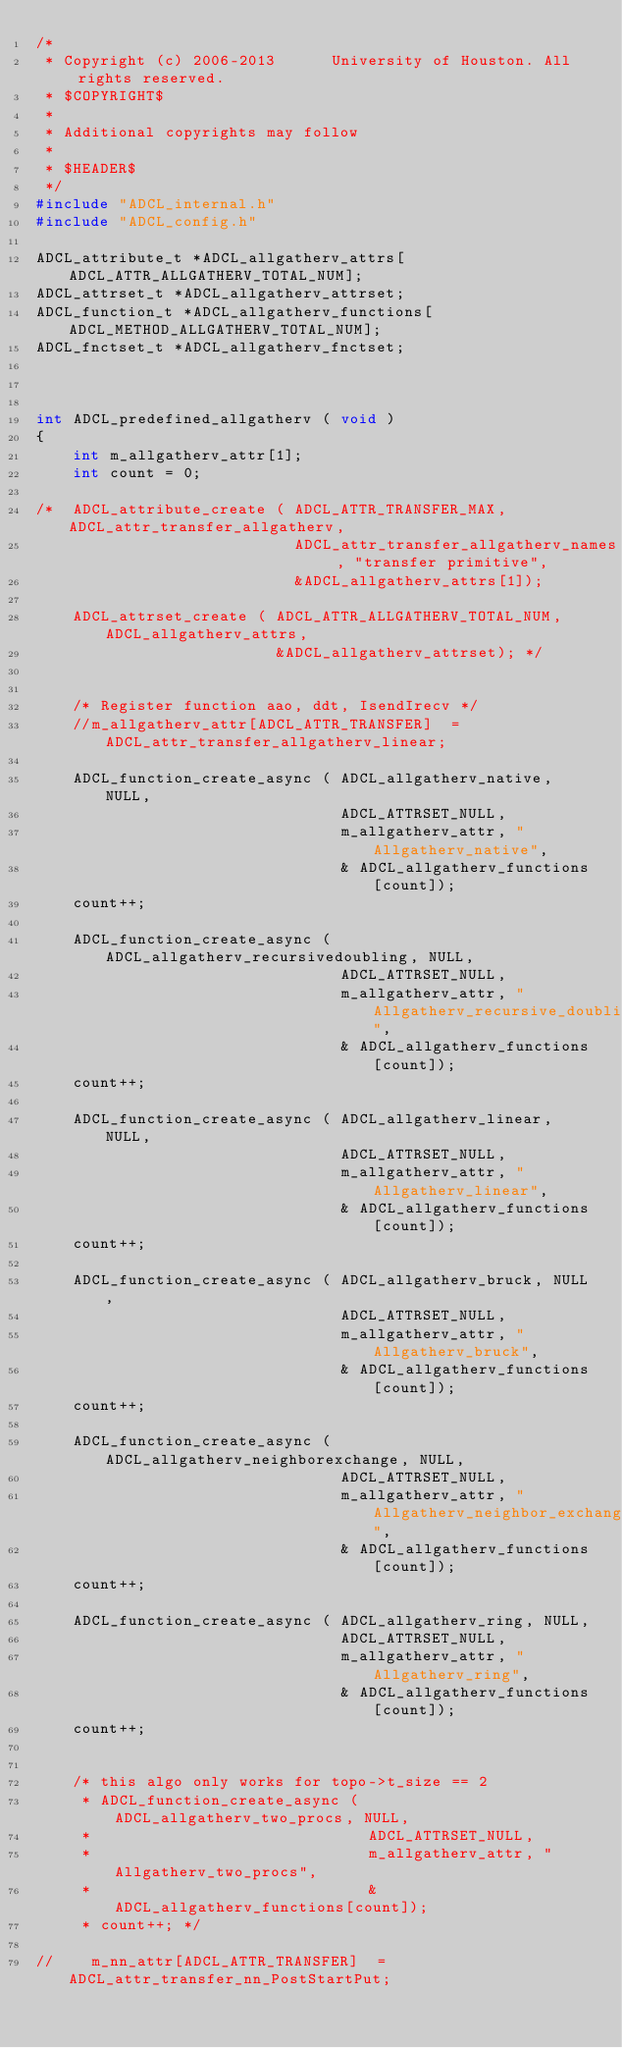<code> <loc_0><loc_0><loc_500><loc_500><_C_>/*
 * Copyright (c) 2006-2013      University of Houston. All rights reserved.
 * $COPYRIGHT$
 *
 * Additional copyrights may follow
 *
 * $HEADER$
 */
#include "ADCL_internal.h"
#include "ADCL_config.h"

ADCL_attribute_t *ADCL_allgatherv_attrs[ADCL_ATTR_ALLGATHERV_TOTAL_NUM];
ADCL_attrset_t *ADCL_allgatherv_attrset;
ADCL_function_t *ADCL_allgatherv_functions[ADCL_METHOD_ALLGATHERV_TOTAL_NUM];
ADCL_fnctset_t *ADCL_allgatherv_fnctset;



int ADCL_predefined_allgatherv ( void )
{
    int m_allgatherv_attr[1];
    int count = 0;

/*  ADCL_attribute_create ( ADCL_ATTR_TRANSFER_MAX, ADCL_attr_transfer_allgatherv,
                            ADCL_attr_transfer_allgatherv_names , "transfer primitive",
                            &ADCL_allgatherv_attrs[1]);

    ADCL_attrset_create ( ADCL_ATTR_ALLGATHERV_TOTAL_NUM, ADCL_allgatherv_attrs,
                          &ADCL_allgatherv_attrset); */


    /* Register function aao, ddt, IsendIrecv */
    //m_allgatherv_attr[ADCL_ATTR_TRANSFER]  = ADCL_attr_transfer_allgatherv_linear;

    ADCL_function_create_async ( ADCL_allgatherv_native, NULL,
                                 ADCL_ATTRSET_NULL,
                                 m_allgatherv_attr, "Allgatherv_native",
                                 & ADCL_allgatherv_functions[count]);
    count++;

    ADCL_function_create_async ( ADCL_allgatherv_recursivedoubling, NULL,
                                 ADCL_ATTRSET_NULL,
                                 m_allgatherv_attr, "Allgatherv_recursive_doubling",
                                 & ADCL_allgatherv_functions[count]);
    count++;

    ADCL_function_create_async ( ADCL_allgatherv_linear, NULL,
                                 ADCL_ATTRSET_NULL,
                                 m_allgatherv_attr, "Allgatherv_linear",
                                 & ADCL_allgatherv_functions[count]);
    count++;

    ADCL_function_create_async ( ADCL_allgatherv_bruck, NULL,
                                 ADCL_ATTRSET_NULL,
                                 m_allgatherv_attr, "Allgatherv_bruck",
                                 & ADCL_allgatherv_functions[count]);
    count++;

    ADCL_function_create_async ( ADCL_allgatherv_neighborexchange, NULL,
                                 ADCL_ATTRSET_NULL,
                                 m_allgatherv_attr, "Allgatherv_neighbor_exchange",
                                 & ADCL_allgatherv_functions[count]);
    count++;

    ADCL_function_create_async ( ADCL_allgatherv_ring, NULL,
                                 ADCL_ATTRSET_NULL,
                                 m_allgatherv_attr, "Allgatherv_ring",
                                 & ADCL_allgatherv_functions[count]);
    count++;


    /* this algo only works for topo->t_size == 2
     * ADCL_function_create_async ( ADCL_allgatherv_two_procs, NULL,
     *                              ADCL_ATTRSET_NULL,
     *                              m_allgatherv_attr, "Allgatherv_two_procs",
     *                              & ADCL_allgatherv_functions[count]);
     * count++; */

//    m_nn_attr[ADCL_ATTR_TRANSFER]  = ADCL_attr_transfer_nn_PostStartPut;</code> 